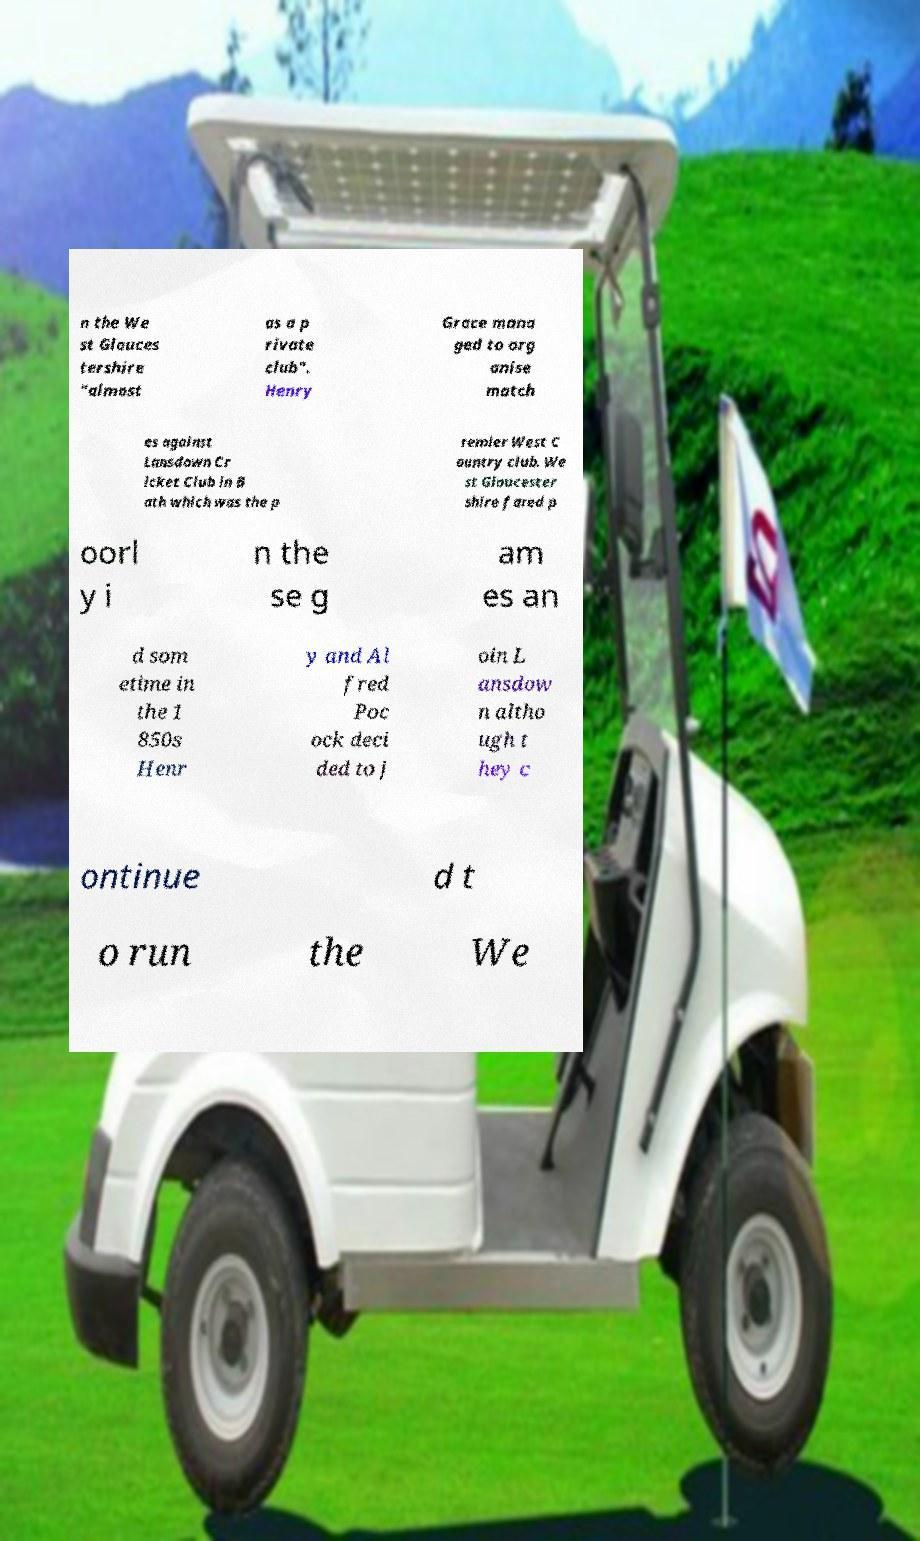Could you extract and type out the text from this image? n the We st Glouces tershire "almost as a p rivate club". Henry Grace mana ged to org anise match es against Lansdown Cr icket Club in B ath which was the p remier West C ountry club. We st Gloucester shire fared p oorl y i n the se g am es an d som etime in the 1 850s Henr y and Al fred Poc ock deci ded to j oin L ansdow n altho ugh t hey c ontinue d t o run the We 